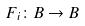Convert formula to latex. <formula><loc_0><loc_0><loc_500><loc_500>F _ { i } \colon B \rightarrow B</formula> 